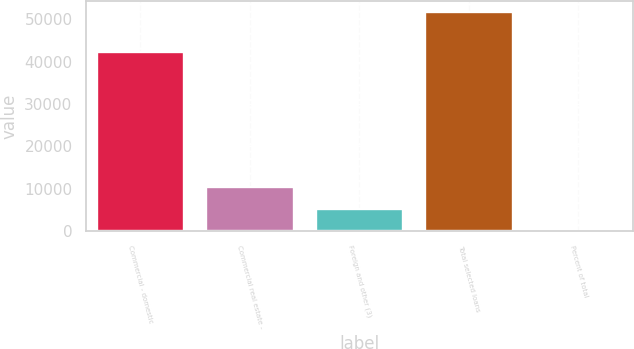Convert chart to OTSL. <chart><loc_0><loc_0><loc_500><loc_500><bar_chart><fcel>Commercial - domestic<fcel>Commercial real estate -<fcel>Foreign and other (3)<fcel>Total selected loans<fcel>Percent of total<nl><fcel>42239<fcel>10344.7<fcel>5180.89<fcel>51655<fcel>17.1<nl></chart> 